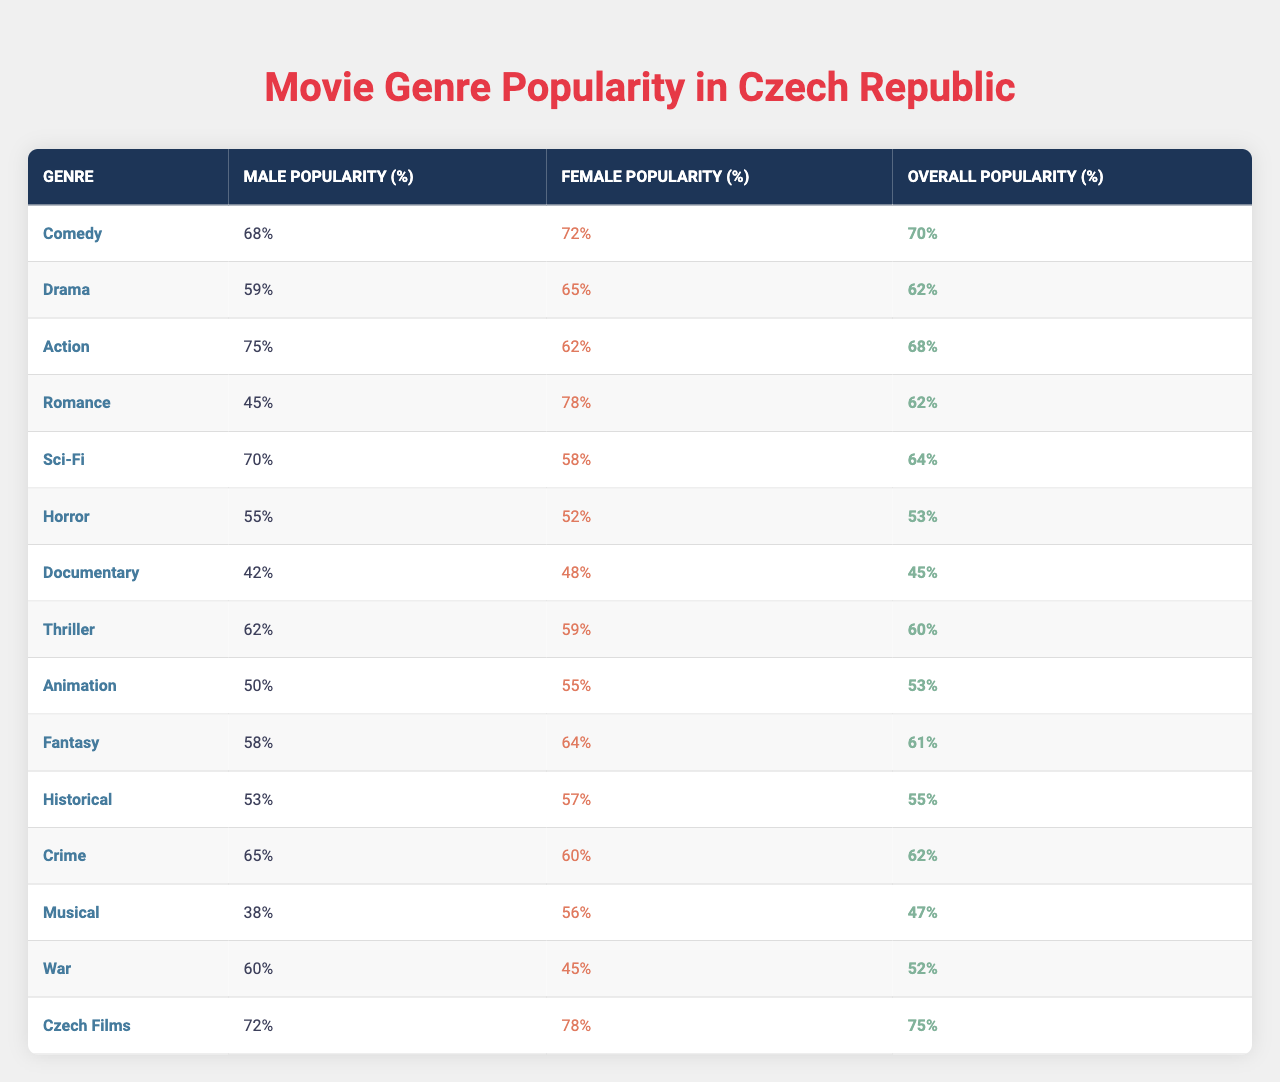What is the most popular movie genre among female audiences in the Czech Republic? Looking at the "Female Popularity (%)" column, the highest percentage is 78% for the "Romance" genre.
Answer: Romance Which genre has the highest popularity among male audiences? The "Action" genre has the highest value in the "Male Popularity (%)" column with 75%.
Answer: Action What is the overall popularity percentage of "Czech Films"? The "Overall Popularity (%)" for "Czech Films" is 75%.
Answer: 75% Which genre is equally popular for both genders? By checking the values in the "Male Popularity (%)" and "Female Popularity (%)" columns, the "Crime" genre shows a close value of 62% for both genders.
Answer: Crime How does the popularity of Sci-Fi compare to Animation among genders? Sci-Fi has a popularity of 70% among males and 58% among females, while Animation has 50% among males and 55% among females. Sci-Fi is more popular among males, and Animation is slightly more popular among females.
Answer: Sci-Fi is more popular among males, Animation is more popular among females What is the average popularity of the "Drama" and "Thriller" genres overall? The overall popularity of "Drama" is 62% and "Thriller" is 60%. To find the average, (62 + 60) / 2 = 61%.
Answer: 61% Is the popularity of "Comedy" higher than that of "Horror" among male audiences? The "Male Popularity (%)" for "Comedy" is 68%, and for "Horror", it is 55%. Since 68% is higher than 55%, the answer is yes.
Answer: Yes What is the difference in popularity between female and male audiences for the "War" genre? The "Female Popularity (%)" for "War" is 45%, and the "Male Popularity (%)" is 60%. The difference is 60% - 45% = 15%.
Answer: 15% Which two genres have the smallest gap in popularity between genders? Looking at the differences between the "Male Popularity (%)" and "Female Popularity (%)" for each genre, the smallest gap is for "Thriller" (3%) as it scores 62% for males and 59% for females.
Answer: Thriller What is the combined popularity percentage for "Animation" and "Musical" among female audiences? The female popularity for "Animation" is 55% and for "Musical" is 56%. Adding these gives 55% + 56% = 111%.
Answer: 111% Which genre has the least popularity overall in the Czech Republic? The overall popularity for "Documentary" is the lowest at 45%.
Answer: Documentary 